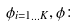Convert formula to latex. <formula><loc_0><loc_0><loc_500><loc_500>\phi _ { i = 1 \dots K } , \phi \colon</formula> 